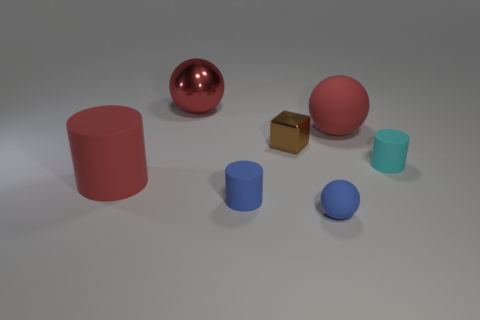Subtract all matte spheres. How many spheres are left? 1 Subtract all blocks. How many objects are left? 6 Add 1 tiny cylinders. How many objects exist? 8 Subtract 3 cylinders. How many cylinders are left? 0 Subtract all cyan cylinders. How many cylinders are left? 2 Subtract all yellow spheres. How many red cubes are left? 0 Subtract all cylinders. Subtract all small rubber things. How many objects are left? 1 Add 1 brown metallic things. How many brown metallic things are left? 2 Add 2 balls. How many balls exist? 5 Subtract 1 red balls. How many objects are left? 6 